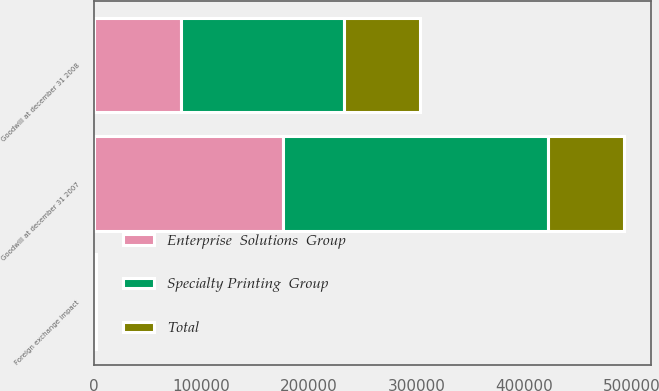Convert chart to OTSL. <chart><loc_0><loc_0><loc_500><loc_500><stacked_bar_chart><ecel><fcel>Goodwill at december 31 2007<fcel>Foreign exchange impact<fcel>Goodwill at december 31 2008<nl><fcel>Enterprise  Solutions  Group<fcel>175812<fcel>585<fcel>80837<nl><fcel>Total<fcel>70698<fcel>179<fcel>70519<nl><fcel>Specialty Printing  Group<fcel>246510<fcel>764<fcel>151356<nl></chart> 